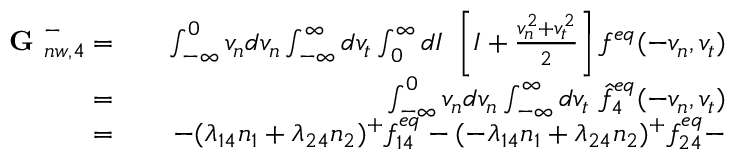Convert formula to latex. <formula><loc_0><loc_0><loc_500><loc_500>\begin{array} { r l r } { G _ { n w , 4 } ^ { - } = } & { \int _ { - \infty } ^ { 0 } v _ { n } d v _ { n } \int _ { - \infty } ^ { \infty } d v _ { t } \int _ { 0 } ^ { \infty } d I \ \left [ I + \frac { v _ { n } ^ { 2 } + v _ { t } ^ { 2 } } { 2 } \right ] f ^ { e q } ( - v _ { n } , v _ { t } ) } \\ { = } & { \int _ { - \infty } ^ { 0 } v _ { n } d v _ { n } \int _ { - \infty } ^ { \infty } d v _ { t } \ \hat { f } _ { 4 } ^ { e q } ( - v _ { n } , v _ { t } ) } \\ { = } & { - ( \lambda _ { 1 4 } n _ { 1 } + \lambda _ { 2 4 } n _ { 2 } ) ^ { + } f _ { 1 4 } ^ { e q } - ( - \lambda _ { 1 4 } n _ { 1 } + \lambda _ { 2 4 } n _ { 2 } ) ^ { + } f _ { 2 4 } ^ { e q } - } \end{array}</formula> 